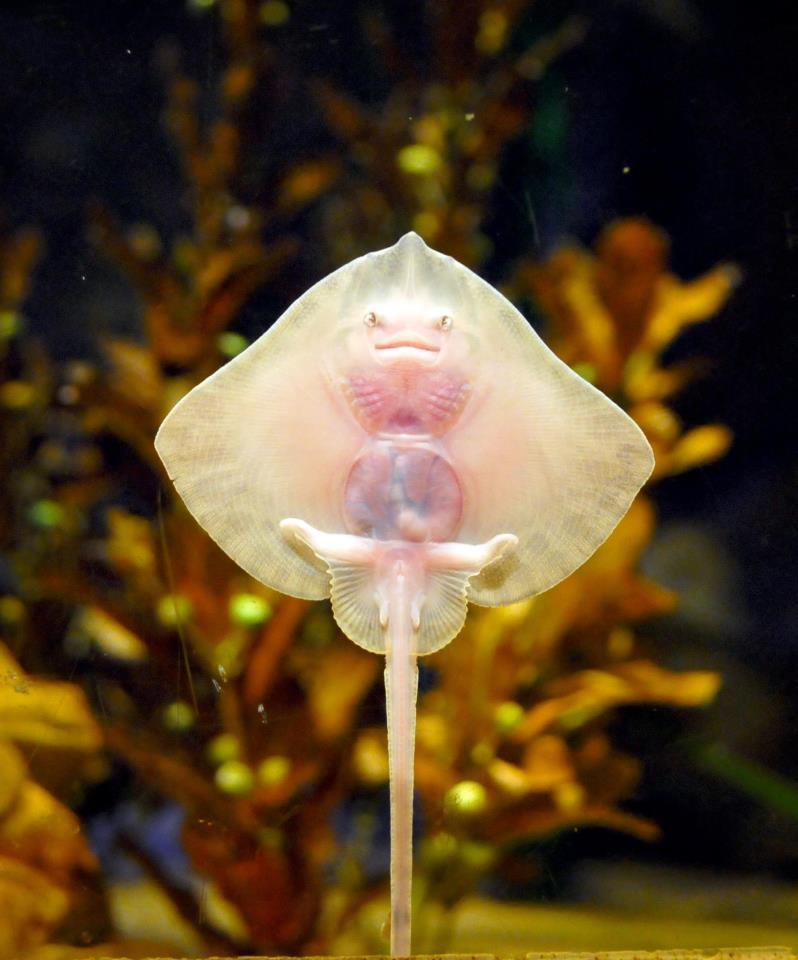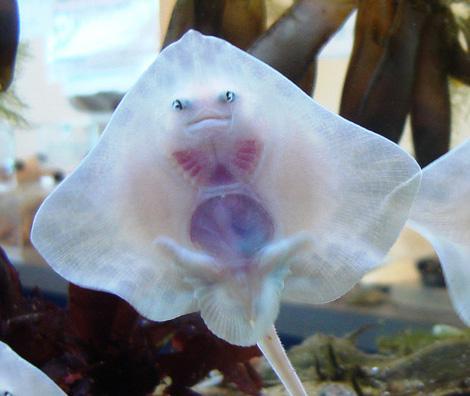The first image is the image on the left, the second image is the image on the right. Given the left and right images, does the statement "There are more rays in the image on the left than in the image on the right." hold true? Answer yes or no. No. 